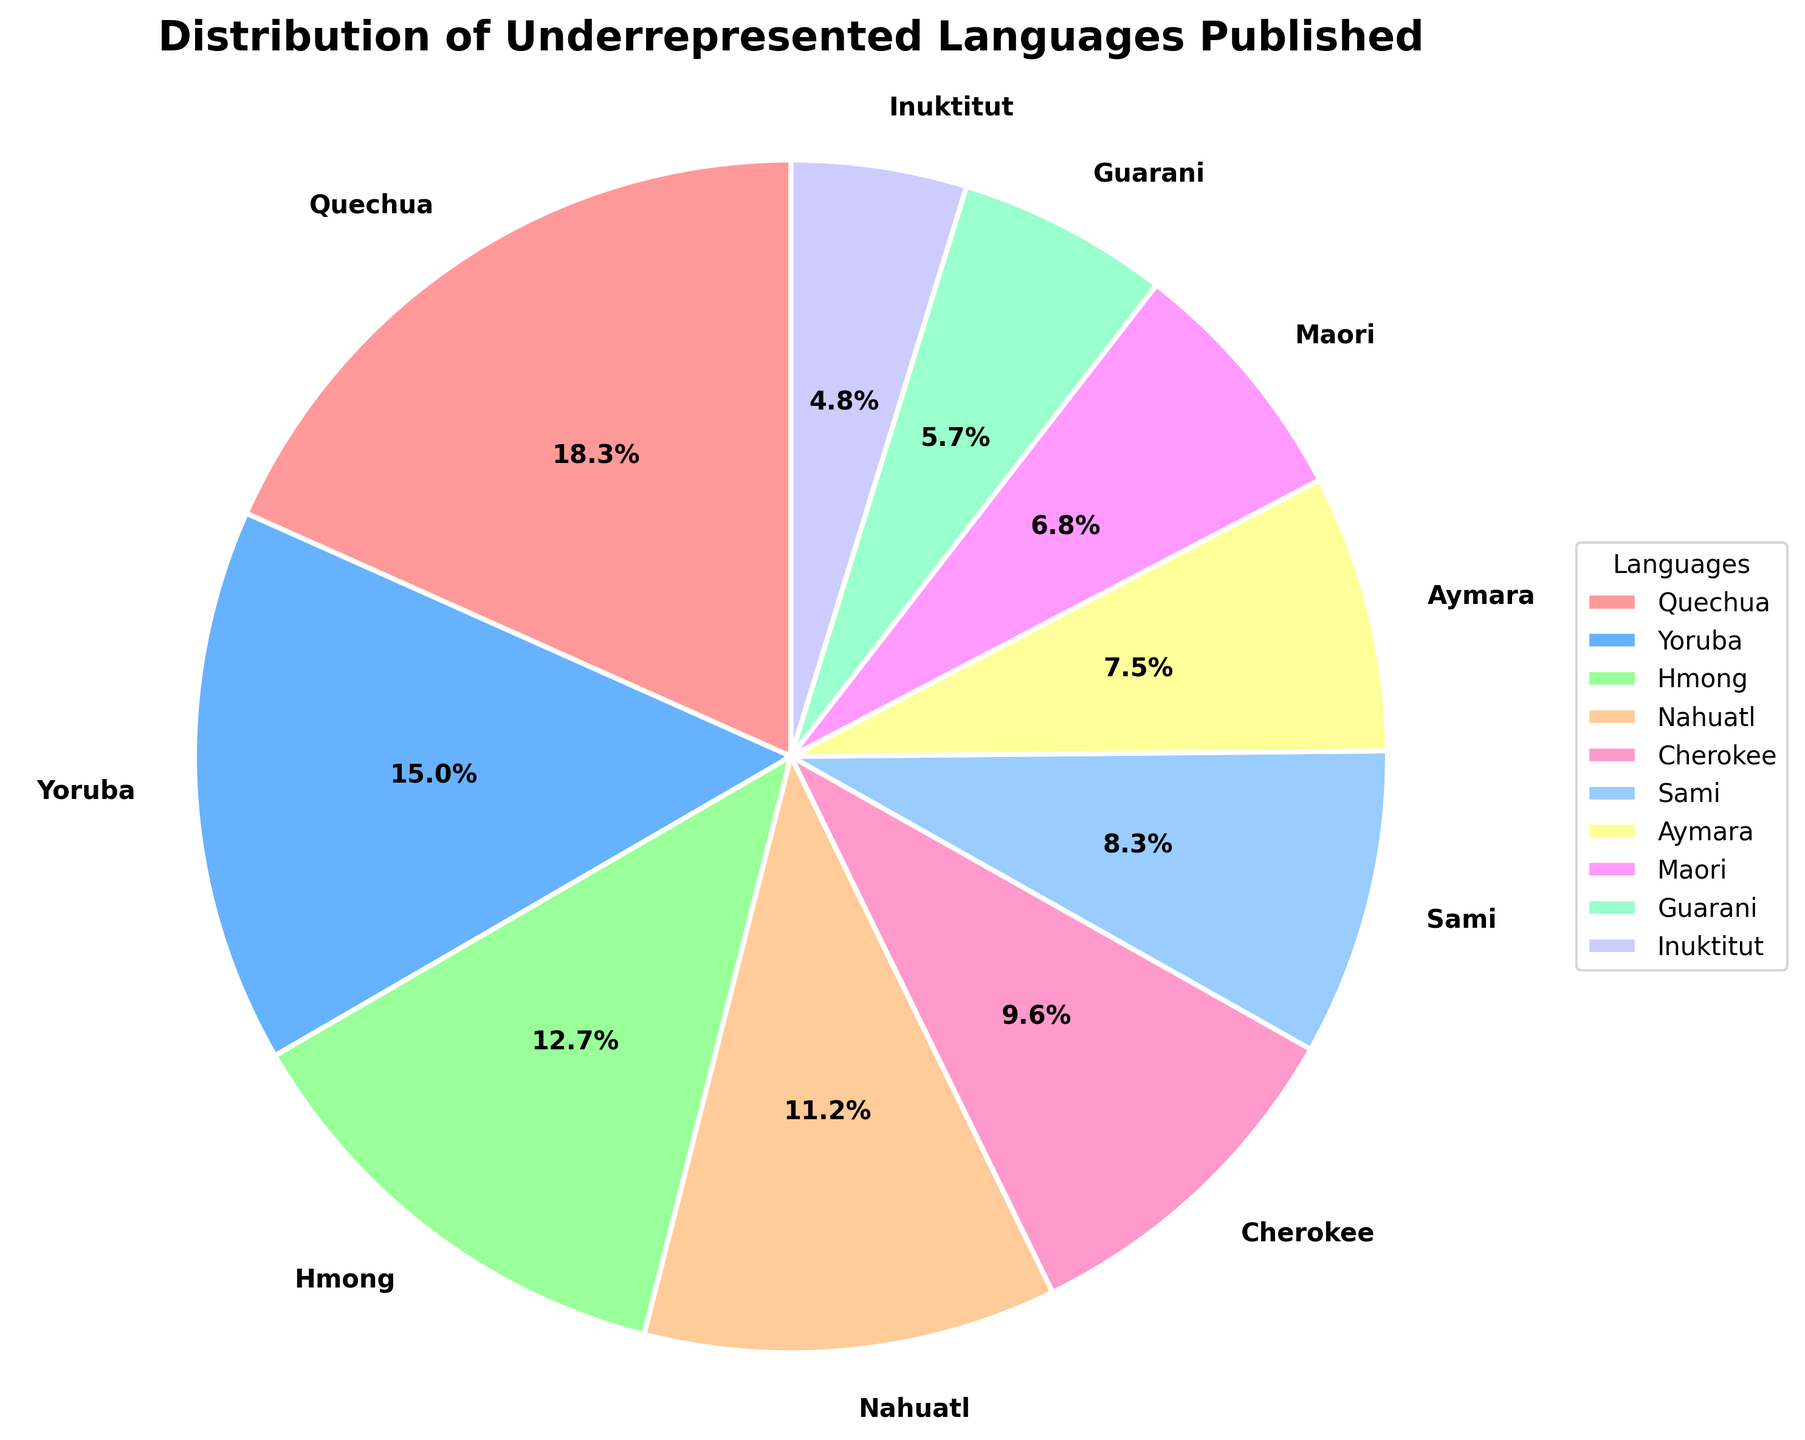What is the highest represented language in the pie chart? The highest represented language can be identified by looking at the slice with the largest percentage. Quechua has the largest slice which represents 18.5%.
Answer: Quechua Which language has a smaller representation: Sami or Cherokee? Compare the percentages of Sami and Cherokee on the pie chart. Sami is represented by 8.4% while Cherokee is represented by 9.7%. Therefore, Sami has a smaller representation.
Answer: Sami What is the combined percentage of Aymara and Maori? To find the combined percentage, add the percentage of Aymara (7.6%) and the percentage of Maori (6.9%). The sum is 7.6% + 6.9% = 14.5%.
Answer: 14.5% How much more percentage does Quechua have compared to Inuktitut? Subtract the percentage of Inuktitut (4.8%) from the percentage of Quechua (18.5%). The difference is 18.5% - 4.8% = 13.7%.
Answer: 13.7% What is the total percentage of the three least represented languages? The three least represented languages are Inuktitut (4.8%), Guarani (5.8%), and Maori (6.9%). The total percentage is calculated by adding these values: 4.8% + 5.8% + 6.9% = 17.5%.
Answer: 17.5% Which language slice is represented by the blue color? Visually inspect the pie chart and identify which language slice is shaded in blue. Yoruba is represented by the blue slice.
Answer: Yoruba Are there more languages with a representation above or below 10%? Count the number of languages that have a percentage above 10%. Quechua (18.5%), Yoruba (15.2%), Hmong (12.8%), and Nahuatl (11.3%) are above 10%, giving a total of 4 languages. Similarly, count those below 10%: Cherokee (9.7%), Sami (8.4%), Aymara (7.6%), Maori (6.9%), Guarani (5.8%), and Inuktitut (4.8%) - a total of 6 languages. There are more languages with a representation below 10%.
Answer: Below 10% What percentage of the languages have a representation of more than 15%? Identify the languages with percentages more than 15%: Quechua (18.5%) and Yoruba (15.2%). This gives 2 out of 10 languages. To find the percentage, (2/10) * 100% = 20%.
Answer: 20% 